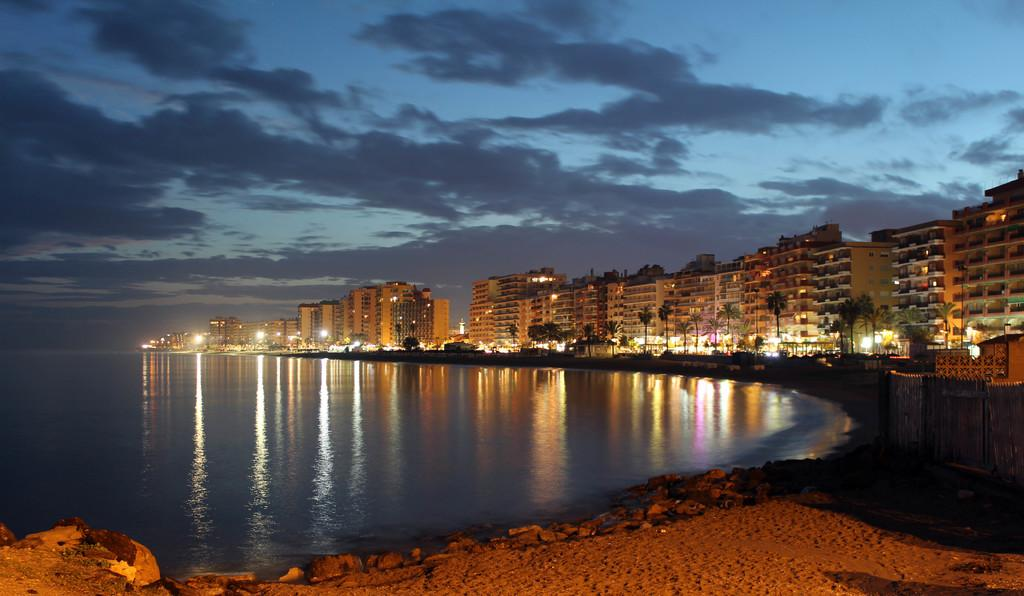What type of landscape is featured in the image? The image features a sea. What structures are located near the sea? There are tall buildings around the sea. What type of vegetation is present in the image? Trees are present in the image. What type of lighting is visible in the image? Street lights are visible in the image. How would you describe the overall scene in the image? The image presents a beautiful view of the city. How does the train pass through the stomach in the image? There is no train or stomach present in the image; it features a sea, tall buildings, trees, street lights, and a beautiful view of the city. 